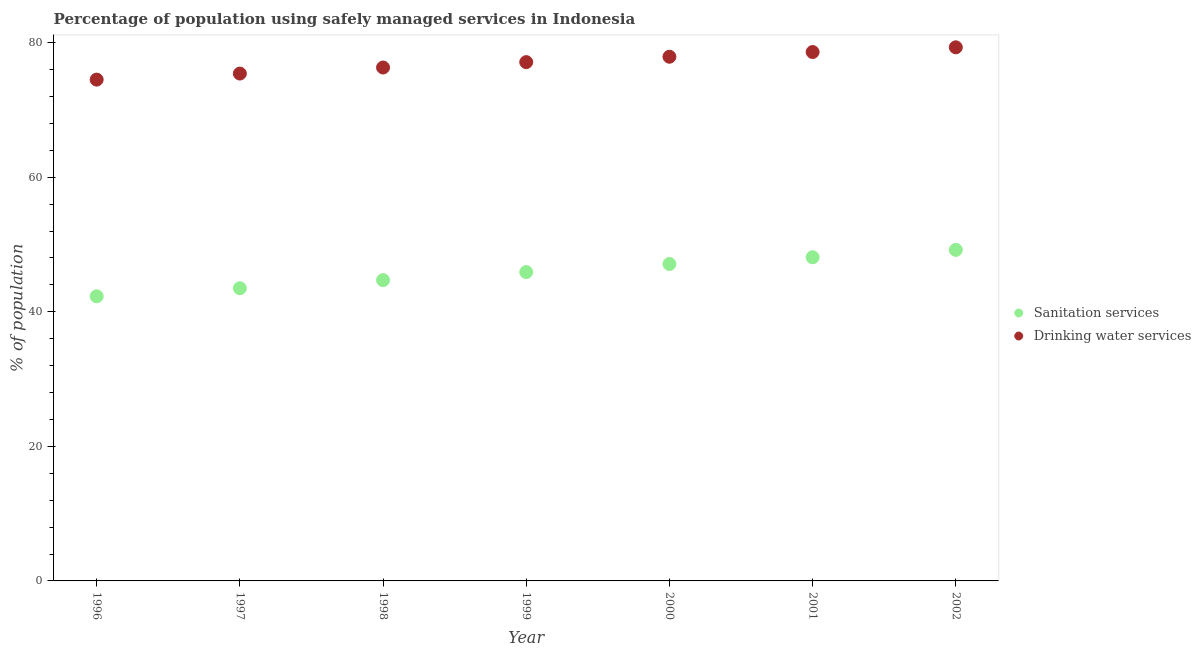How many different coloured dotlines are there?
Make the answer very short. 2. What is the percentage of population who used sanitation services in 2002?
Provide a short and direct response. 49.2. Across all years, what is the maximum percentage of population who used sanitation services?
Make the answer very short. 49.2. Across all years, what is the minimum percentage of population who used drinking water services?
Your response must be concise. 74.5. What is the total percentage of population who used drinking water services in the graph?
Provide a short and direct response. 539.1. What is the difference between the percentage of population who used drinking water services in 2000 and that in 2002?
Make the answer very short. -1.4. What is the difference between the percentage of population who used sanitation services in 2001 and the percentage of population who used drinking water services in 2000?
Your answer should be very brief. -29.8. What is the average percentage of population who used sanitation services per year?
Your answer should be very brief. 45.83. In the year 1999, what is the difference between the percentage of population who used drinking water services and percentage of population who used sanitation services?
Offer a very short reply. 31.2. What is the ratio of the percentage of population who used sanitation services in 1996 to that in 2000?
Make the answer very short. 0.9. Is the difference between the percentage of population who used drinking water services in 1997 and 2000 greater than the difference between the percentage of population who used sanitation services in 1997 and 2000?
Give a very brief answer. Yes. What is the difference between the highest and the second highest percentage of population who used drinking water services?
Offer a very short reply. 0.7. What is the difference between the highest and the lowest percentage of population who used sanitation services?
Provide a short and direct response. 6.9. In how many years, is the percentage of population who used drinking water services greater than the average percentage of population who used drinking water services taken over all years?
Provide a short and direct response. 4. Is the sum of the percentage of population who used drinking water services in 1996 and 1999 greater than the maximum percentage of population who used sanitation services across all years?
Ensure brevity in your answer.  Yes. Does the percentage of population who used drinking water services monotonically increase over the years?
Provide a succinct answer. Yes. Is the percentage of population who used sanitation services strictly less than the percentage of population who used drinking water services over the years?
Keep it short and to the point. Yes. How many dotlines are there?
Your answer should be compact. 2. How many years are there in the graph?
Give a very brief answer. 7. Does the graph contain any zero values?
Make the answer very short. No. Where does the legend appear in the graph?
Provide a succinct answer. Center right. What is the title of the graph?
Your answer should be compact. Percentage of population using safely managed services in Indonesia. Does "IMF concessional" appear as one of the legend labels in the graph?
Give a very brief answer. No. What is the label or title of the Y-axis?
Your answer should be compact. % of population. What is the % of population of Sanitation services in 1996?
Provide a succinct answer. 42.3. What is the % of population of Drinking water services in 1996?
Keep it short and to the point. 74.5. What is the % of population in Sanitation services in 1997?
Provide a succinct answer. 43.5. What is the % of population of Drinking water services in 1997?
Offer a terse response. 75.4. What is the % of population of Sanitation services in 1998?
Offer a terse response. 44.7. What is the % of population in Drinking water services in 1998?
Give a very brief answer. 76.3. What is the % of population of Sanitation services in 1999?
Your answer should be very brief. 45.9. What is the % of population of Drinking water services in 1999?
Provide a succinct answer. 77.1. What is the % of population in Sanitation services in 2000?
Your response must be concise. 47.1. What is the % of population in Drinking water services in 2000?
Provide a succinct answer. 77.9. What is the % of population in Sanitation services in 2001?
Give a very brief answer. 48.1. What is the % of population of Drinking water services in 2001?
Make the answer very short. 78.6. What is the % of population in Sanitation services in 2002?
Your answer should be compact. 49.2. What is the % of population of Drinking water services in 2002?
Offer a terse response. 79.3. Across all years, what is the maximum % of population in Sanitation services?
Your answer should be very brief. 49.2. Across all years, what is the maximum % of population of Drinking water services?
Provide a short and direct response. 79.3. Across all years, what is the minimum % of population in Sanitation services?
Your answer should be compact. 42.3. Across all years, what is the minimum % of population in Drinking water services?
Your answer should be very brief. 74.5. What is the total % of population of Sanitation services in the graph?
Provide a succinct answer. 320.8. What is the total % of population in Drinking water services in the graph?
Give a very brief answer. 539.1. What is the difference between the % of population of Sanitation services in 1996 and that in 1997?
Give a very brief answer. -1.2. What is the difference between the % of population in Sanitation services in 1996 and that in 1998?
Provide a short and direct response. -2.4. What is the difference between the % of population of Drinking water services in 1996 and that in 1999?
Make the answer very short. -2.6. What is the difference between the % of population in Sanitation services in 1996 and that in 2000?
Provide a succinct answer. -4.8. What is the difference between the % of population of Drinking water services in 1996 and that in 2000?
Your response must be concise. -3.4. What is the difference between the % of population of Drinking water services in 1996 and that in 2002?
Make the answer very short. -4.8. What is the difference between the % of population in Sanitation services in 1997 and that in 1999?
Your response must be concise. -2.4. What is the difference between the % of population of Drinking water services in 1997 and that in 1999?
Your answer should be compact. -1.7. What is the difference between the % of population of Sanitation services in 1997 and that in 2000?
Your answer should be very brief. -3.6. What is the difference between the % of population in Drinking water services in 1997 and that in 2000?
Provide a short and direct response. -2.5. What is the difference between the % of population in Drinking water services in 1997 and that in 2002?
Your response must be concise. -3.9. What is the difference between the % of population in Drinking water services in 1998 and that in 1999?
Your answer should be very brief. -0.8. What is the difference between the % of population of Sanitation services in 1998 and that in 2001?
Give a very brief answer. -3.4. What is the difference between the % of population in Sanitation services in 1998 and that in 2002?
Give a very brief answer. -4.5. What is the difference between the % of population in Drinking water services in 1998 and that in 2002?
Provide a succinct answer. -3. What is the difference between the % of population of Sanitation services in 1999 and that in 2000?
Provide a succinct answer. -1.2. What is the difference between the % of population in Drinking water services in 1999 and that in 2002?
Offer a terse response. -2.2. What is the difference between the % of population in Sanitation services in 2000 and that in 2001?
Your response must be concise. -1. What is the difference between the % of population in Drinking water services in 2000 and that in 2001?
Your answer should be very brief. -0.7. What is the difference between the % of population in Sanitation services in 2001 and that in 2002?
Your answer should be compact. -1.1. What is the difference between the % of population of Drinking water services in 2001 and that in 2002?
Your answer should be very brief. -0.7. What is the difference between the % of population of Sanitation services in 1996 and the % of population of Drinking water services in 1997?
Keep it short and to the point. -33.1. What is the difference between the % of population of Sanitation services in 1996 and the % of population of Drinking water services in 1998?
Provide a short and direct response. -34. What is the difference between the % of population in Sanitation services in 1996 and the % of population in Drinking water services in 1999?
Make the answer very short. -34.8. What is the difference between the % of population in Sanitation services in 1996 and the % of population in Drinking water services in 2000?
Offer a very short reply. -35.6. What is the difference between the % of population in Sanitation services in 1996 and the % of population in Drinking water services in 2001?
Provide a short and direct response. -36.3. What is the difference between the % of population of Sanitation services in 1996 and the % of population of Drinking water services in 2002?
Offer a terse response. -37. What is the difference between the % of population of Sanitation services in 1997 and the % of population of Drinking water services in 1998?
Keep it short and to the point. -32.8. What is the difference between the % of population of Sanitation services in 1997 and the % of population of Drinking water services in 1999?
Your response must be concise. -33.6. What is the difference between the % of population of Sanitation services in 1997 and the % of population of Drinking water services in 2000?
Offer a terse response. -34.4. What is the difference between the % of population of Sanitation services in 1997 and the % of population of Drinking water services in 2001?
Make the answer very short. -35.1. What is the difference between the % of population in Sanitation services in 1997 and the % of population in Drinking water services in 2002?
Make the answer very short. -35.8. What is the difference between the % of population in Sanitation services in 1998 and the % of population in Drinking water services in 1999?
Ensure brevity in your answer.  -32.4. What is the difference between the % of population in Sanitation services in 1998 and the % of population in Drinking water services in 2000?
Your answer should be very brief. -33.2. What is the difference between the % of population of Sanitation services in 1998 and the % of population of Drinking water services in 2001?
Offer a very short reply. -33.9. What is the difference between the % of population in Sanitation services in 1998 and the % of population in Drinking water services in 2002?
Your response must be concise. -34.6. What is the difference between the % of population of Sanitation services in 1999 and the % of population of Drinking water services in 2000?
Give a very brief answer. -32. What is the difference between the % of population of Sanitation services in 1999 and the % of population of Drinking water services in 2001?
Keep it short and to the point. -32.7. What is the difference between the % of population of Sanitation services in 1999 and the % of population of Drinking water services in 2002?
Your response must be concise. -33.4. What is the difference between the % of population of Sanitation services in 2000 and the % of population of Drinking water services in 2001?
Give a very brief answer. -31.5. What is the difference between the % of population in Sanitation services in 2000 and the % of population in Drinking water services in 2002?
Offer a very short reply. -32.2. What is the difference between the % of population in Sanitation services in 2001 and the % of population in Drinking water services in 2002?
Offer a terse response. -31.2. What is the average % of population of Sanitation services per year?
Give a very brief answer. 45.83. What is the average % of population in Drinking water services per year?
Your answer should be very brief. 77.01. In the year 1996, what is the difference between the % of population of Sanitation services and % of population of Drinking water services?
Provide a succinct answer. -32.2. In the year 1997, what is the difference between the % of population of Sanitation services and % of population of Drinking water services?
Your response must be concise. -31.9. In the year 1998, what is the difference between the % of population of Sanitation services and % of population of Drinking water services?
Your response must be concise. -31.6. In the year 1999, what is the difference between the % of population of Sanitation services and % of population of Drinking water services?
Make the answer very short. -31.2. In the year 2000, what is the difference between the % of population in Sanitation services and % of population in Drinking water services?
Keep it short and to the point. -30.8. In the year 2001, what is the difference between the % of population of Sanitation services and % of population of Drinking water services?
Offer a very short reply. -30.5. In the year 2002, what is the difference between the % of population in Sanitation services and % of population in Drinking water services?
Offer a terse response. -30.1. What is the ratio of the % of population in Sanitation services in 1996 to that in 1997?
Provide a short and direct response. 0.97. What is the ratio of the % of population of Sanitation services in 1996 to that in 1998?
Your answer should be compact. 0.95. What is the ratio of the % of population of Drinking water services in 1996 to that in 1998?
Offer a terse response. 0.98. What is the ratio of the % of population of Sanitation services in 1996 to that in 1999?
Give a very brief answer. 0.92. What is the ratio of the % of population in Drinking water services in 1996 to that in 1999?
Your answer should be very brief. 0.97. What is the ratio of the % of population of Sanitation services in 1996 to that in 2000?
Your answer should be compact. 0.9. What is the ratio of the % of population in Drinking water services in 1996 to that in 2000?
Ensure brevity in your answer.  0.96. What is the ratio of the % of population in Sanitation services in 1996 to that in 2001?
Ensure brevity in your answer.  0.88. What is the ratio of the % of population in Drinking water services in 1996 to that in 2001?
Offer a very short reply. 0.95. What is the ratio of the % of population in Sanitation services in 1996 to that in 2002?
Offer a very short reply. 0.86. What is the ratio of the % of population of Drinking water services in 1996 to that in 2002?
Offer a very short reply. 0.94. What is the ratio of the % of population in Sanitation services in 1997 to that in 1998?
Offer a very short reply. 0.97. What is the ratio of the % of population of Sanitation services in 1997 to that in 1999?
Offer a terse response. 0.95. What is the ratio of the % of population of Sanitation services in 1997 to that in 2000?
Your answer should be very brief. 0.92. What is the ratio of the % of population in Drinking water services in 1997 to that in 2000?
Your answer should be compact. 0.97. What is the ratio of the % of population in Sanitation services in 1997 to that in 2001?
Your answer should be very brief. 0.9. What is the ratio of the % of population of Drinking water services in 1997 to that in 2001?
Provide a short and direct response. 0.96. What is the ratio of the % of population of Sanitation services in 1997 to that in 2002?
Ensure brevity in your answer.  0.88. What is the ratio of the % of population of Drinking water services in 1997 to that in 2002?
Offer a terse response. 0.95. What is the ratio of the % of population of Sanitation services in 1998 to that in 1999?
Offer a very short reply. 0.97. What is the ratio of the % of population of Sanitation services in 1998 to that in 2000?
Offer a very short reply. 0.95. What is the ratio of the % of population of Drinking water services in 1998 to that in 2000?
Your answer should be compact. 0.98. What is the ratio of the % of population of Sanitation services in 1998 to that in 2001?
Make the answer very short. 0.93. What is the ratio of the % of population of Drinking water services in 1998 to that in 2001?
Give a very brief answer. 0.97. What is the ratio of the % of population in Sanitation services in 1998 to that in 2002?
Your response must be concise. 0.91. What is the ratio of the % of population of Drinking water services in 1998 to that in 2002?
Your response must be concise. 0.96. What is the ratio of the % of population of Sanitation services in 1999 to that in 2000?
Your answer should be very brief. 0.97. What is the ratio of the % of population in Drinking water services in 1999 to that in 2000?
Give a very brief answer. 0.99. What is the ratio of the % of population of Sanitation services in 1999 to that in 2001?
Keep it short and to the point. 0.95. What is the ratio of the % of population of Drinking water services in 1999 to that in 2001?
Your answer should be very brief. 0.98. What is the ratio of the % of population in Sanitation services in 1999 to that in 2002?
Make the answer very short. 0.93. What is the ratio of the % of population of Drinking water services in 1999 to that in 2002?
Provide a succinct answer. 0.97. What is the ratio of the % of population of Sanitation services in 2000 to that in 2001?
Your answer should be compact. 0.98. What is the ratio of the % of population of Drinking water services in 2000 to that in 2001?
Your answer should be compact. 0.99. What is the ratio of the % of population in Sanitation services in 2000 to that in 2002?
Your answer should be compact. 0.96. What is the ratio of the % of population of Drinking water services in 2000 to that in 2002?
Provide a succinct answer. 0.98. What is the ratio of the % of population in Sanitation services in 2001 to that in 2002?
Provide a short and direct response. 0.98. What is the ratio of the % of population in Drinking water services in 2001 to that in 2002?
Offer a terse response. 0.99. What is the difference between the highest and the second highest % of population of Sanitation services?
Ensure brevity in your answer.  1.1. What is the difference between the highest and the lowest % of population of Sanitation services?
Keep it short and to the point. 6.9. 